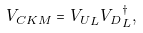Convert formula to latex. <formula><loc_0><loc_0><loc_500><loc_500>V _ { C K M } = { V _ { U } } _ { L } { V _ { D } } _ { L } ^ { \dagger } ,</formula> 